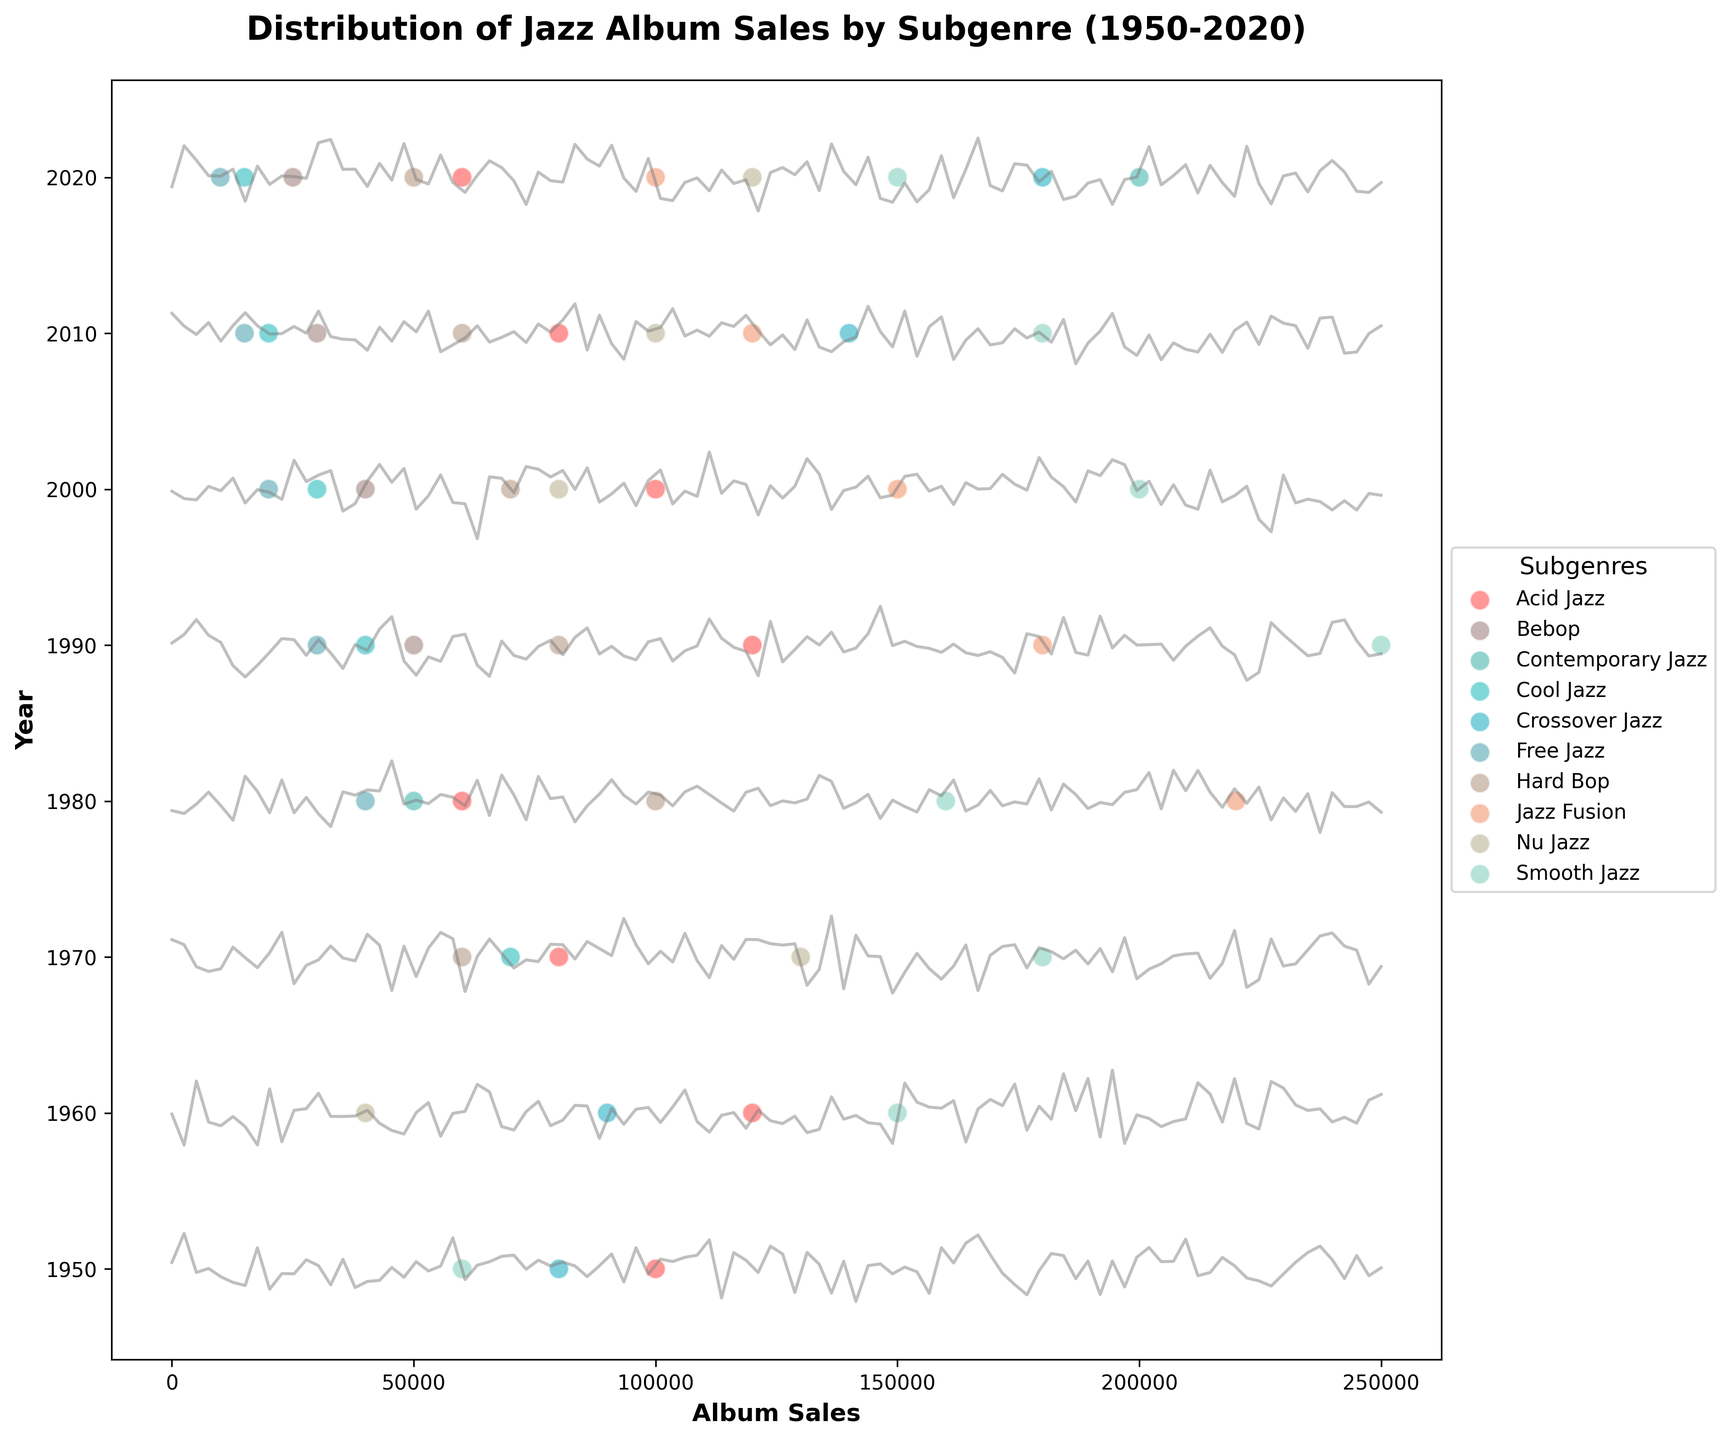What is the title of the figure? The title of the figure is usually located at the top and gives an overview of what the figure is about. In this case, it mentions the distribution of jazz album sales by subgenre over time.
Answer: Distribution of Jazz Album Sales by Subgenre (1950-2020) Which year shows the highest sales for the Bebop subgenre? To find the highest sales for the Bebop subgenre, look at the scatter points for Bebop across different years and identify the year with the highest value on the x-axis.
Answer: 1960 What are the y-axis labels, and what do they represent? The y-axis labels are positioned along the vertical axis and represent different years in this plot. They indicate the specific years for which the album sales data are displayed.
Answer: Years (1950, 1960, 1970, 1980, 1990, 2000, 2010, 2020) Between which two subgenres is there the most noticeable increase in sales between 1960 and 1970? Compare the scatter points for different subgenres in 1960 and 1970. Identify the subgenres that show a significant rise in their sales values on the x-axis.
Answer: Jazz Fusion and Bebop Which subgenre shows a decline in album sales from 1950 to 2020? To determine which subgenres show a decline in album sales over time, look at the trend of their scatter points across the years from 1950 to 2020.
Answer: Bebop How many subgenres have data points in the year 1990? Count the number of different subgenre names represented by scatter points in the year 1990 on the y-axis.
Answer: Seven Which subgenre has the most consistent sales across all years? Consistent sales would mean minimal fluctuations in scatter point positions across different years. Check the subgenre that maintains a more level trend over the years.
Answer: Smooth Jazz In which year does Nu Jazz first appear in the data? Look for the first occurrence of a scatter point representing the Nu Jazz subgenre along the y-axis labels.
Answer: 2000 What is the average sales of Acid Jazz in the years it appears? Identify the sales values for Acid Jazz over the years (1990, 2000, 2010, 2020), sum them up, and divide by the number of years it appears.
Answer: (120000 + 100000 + 80000 + 60000) / 4 = 90000 Which subgenre had the highest sales in 2020? In the year 2020 on the y-axis, find the scatter point with the highest value on the x-axis and note its corresponding subgenre.
Answer: Contemporary Jazz 